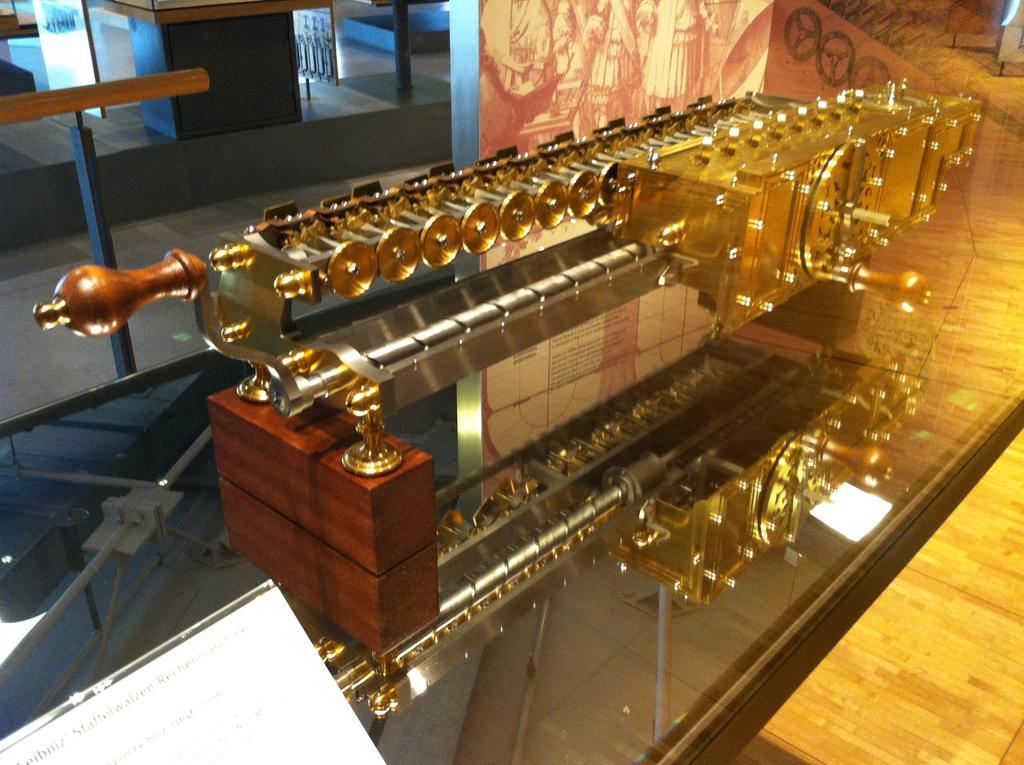Describe this image in one or two sentences. This is a machine, this is wooden object. 